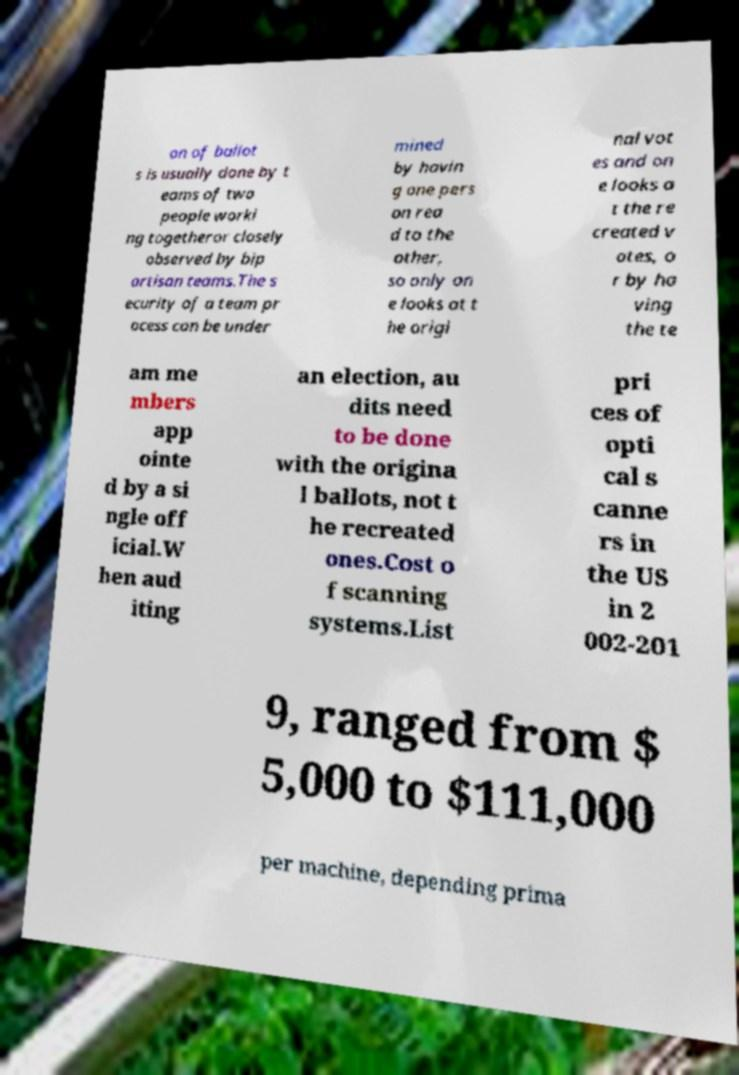Can you accurately transcribe the text from the provided image for me? on of ballot s is usually done by t eams of two people worki ng togetheror closely observed by bip artisan teams.The s ecurity of a team pr ocess can be under mined by havin g one pers on rea d to the other, so only on e looks at t he origi nal vot es and on e looks a t the re created v otes, o r by ha ving the te am me mbers app ointe d by a si ngle off icial.W hen aud iting an election, au dits need to be done with the origina l ballots, not t he recreated ones.Cost o f scanning systems.List pri ces of opti cal s canne rs in the US in 2 002-201 9, ranged from $ 5,000 to $111,000 per machine, depending prima 